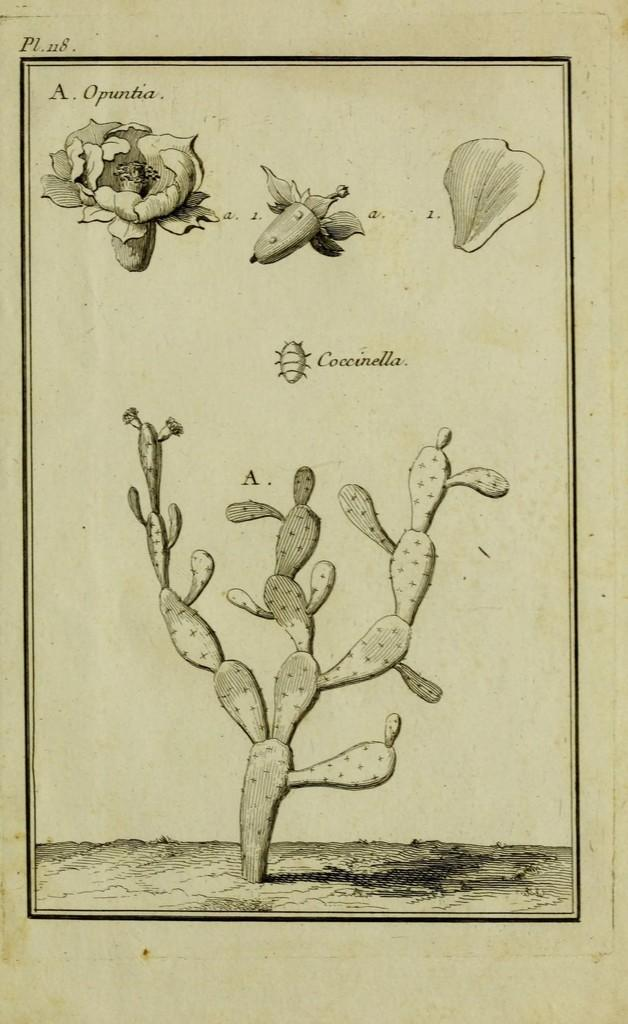What type of visual is depicted in the image? The image appears to be a poster. What can be seen at the bottom of the poster? There is ground at the bottom of the image. What type of plant is featured in the image? There is a cactus plant in the image. What other types of vegetation can be seen in the image? There are flowers and a leaf in the image. Is there any text present in the image? Yes, there is text in the image. What type of wrist accessory is shown in the image? There is no wrist accessory present in the image. What type of order is being placed in the image? There is no order being placed in the image; it features a poster with a cactus plant, flowers, and text. 